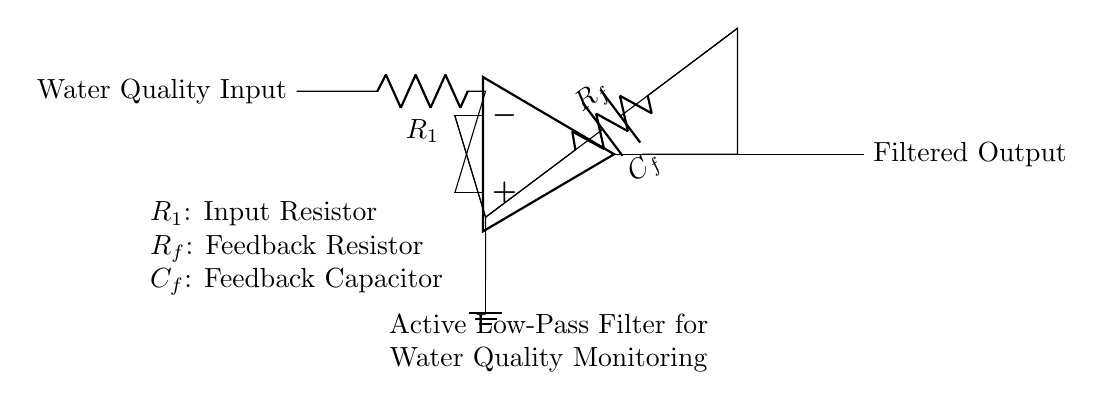What is the input to this circuit? The input to this circuit is labeled as "Water Quality Input," indicating it receives water quality measurements for processing.
Answer: Water Quality Input What does the feedback loop connect to? The feedback loop connects the output of the operational amplifier back to the inverting input, which is a characteristic of feedback in amplifying circuits.
Answer: Inverting input What type of filter is represented in this circuit? This circuit is an active low-pass filter, which allows low-frequency signals to pass while attenuating higher frequencies, as indicated by the component configuration.
Answer: Active low-pass filter What is the function of the capacitor in the feedback loop? The capacitor functions to stabilize the feedback in the circuit and shape the frequency response, which is essential for filtering out unwanted frequencies.
Answer: Stabilization What are the components used in this circuit? The components used in this circuit include an operational amplifier, resistor R1, feedback resistor Rf, and feedback capacitor Cf, all of which are critical for its operation.
Answer: Operational amplifier, R1, Rf, Cf How does the filter affect water quality signals? The filter alters the water quality signals by attenuating high-frequency noise, making the output a cleaner representation of actual water quality readings, which is crucial for monitoring.
Answer: Attenuates high-frequency noise 